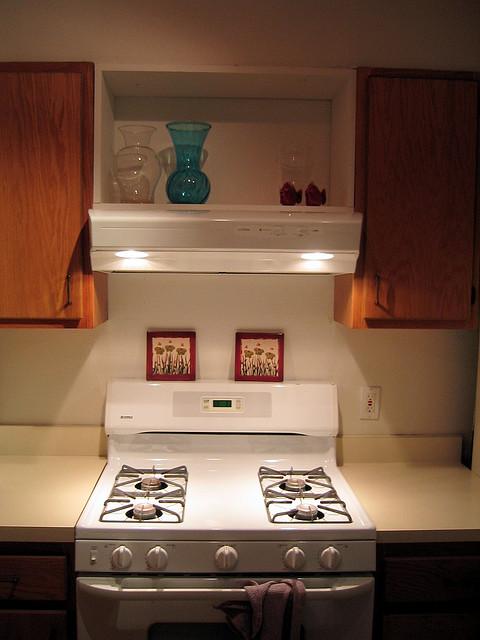What color is the stove?
Write a very short answer. White. Is this kitchen being used?
Give a very brief answer. No. What color is the vase on the right?
Keep it brief. Blue. What room is this?
Keep it brief. Kitchen. Is the stove ready to be used?
Quick response, please. Yes. 